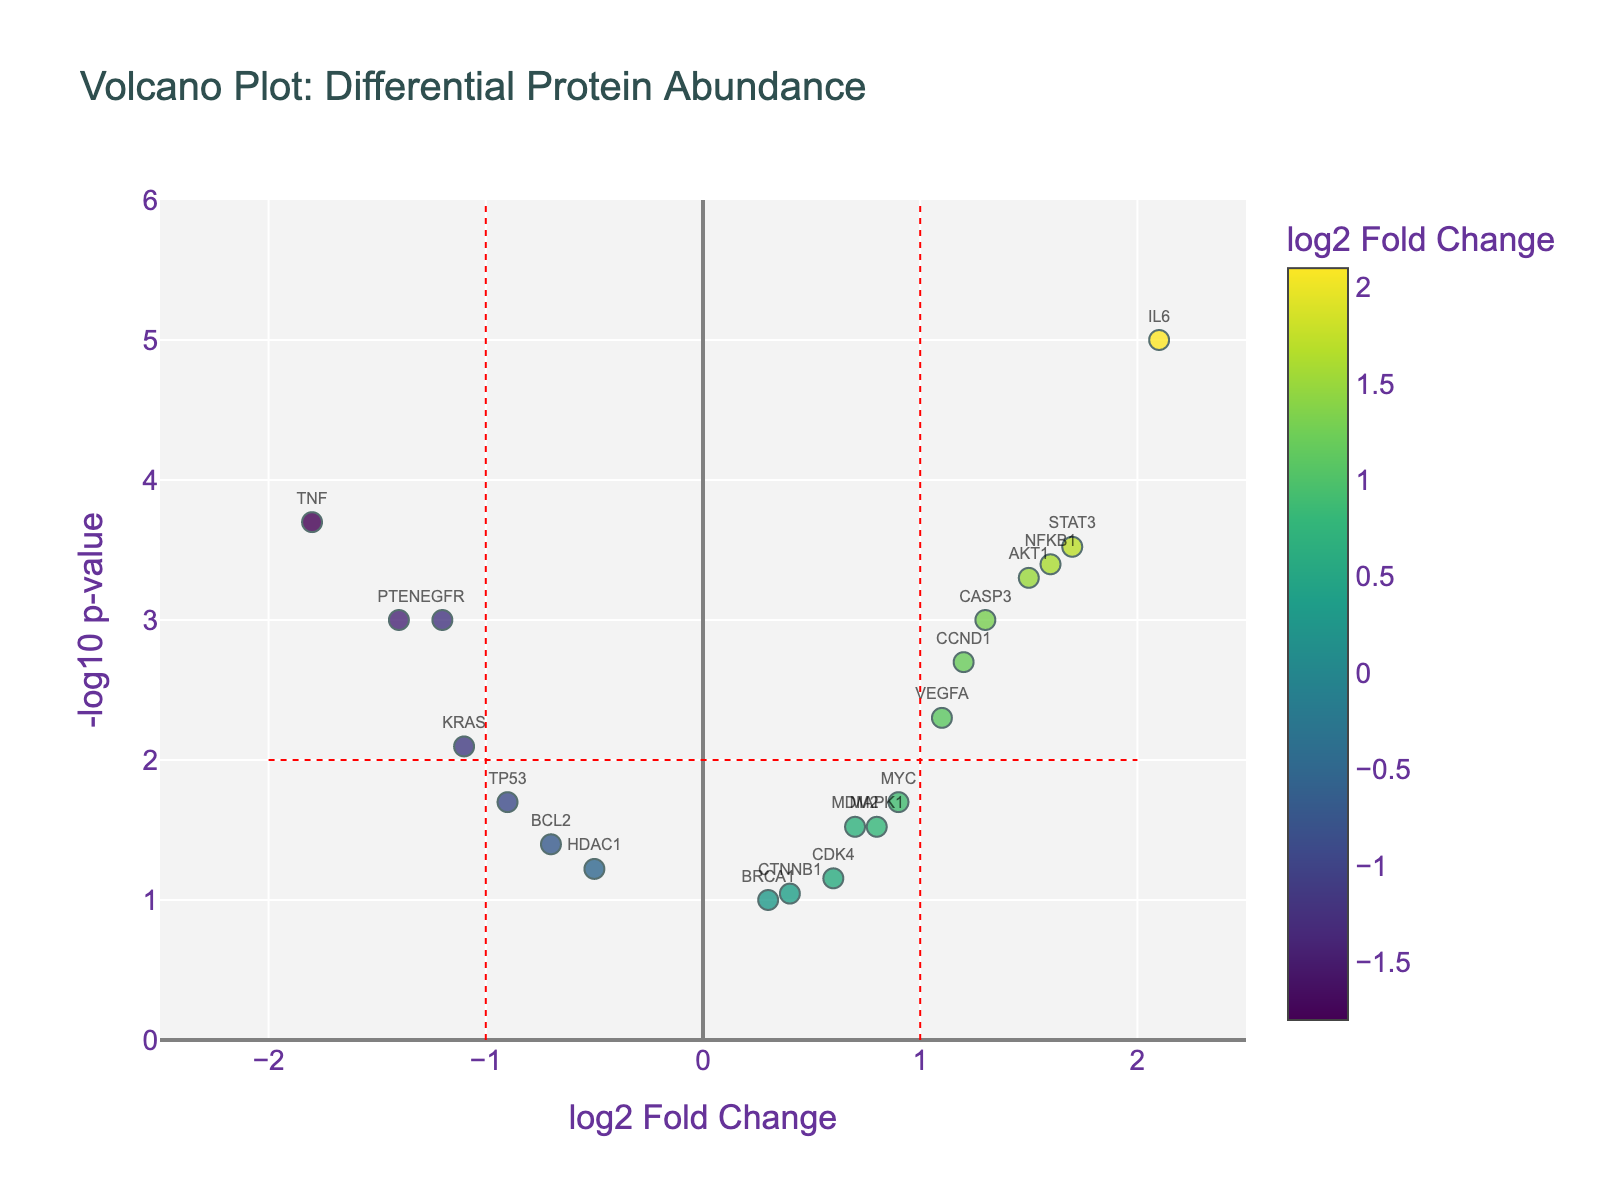Which protein shows the highest log2 fold change? By examining the x-axis (log2 Fold Change), we can see that IL6 has the highest value at 2.1, which is furthest to the right on the plot.
Answer: IL6 Which protein has the lowest p-value? By examining the y-axis (-log10 p-value), we find that IL6 has the highest -log10 p-value, indicating the lowest p-value of 0.00001.
Answer: IL6 Which proteins are significantly upregulated (log2 fold change > 1)? Proteins with log2 fold change > 1 are AKT1, STAT3, CCND1, VEGFA, and CASP3. These are visible on the right side of the vertical line at log2 fold change = 1.
Answer: AKT1, STAT3, CCND1, VEGFA, CASP3 How many proteins have a log2 fold change between -1 and 1? We count the data points between the vertical lines at -1 and 1 on the x-axis. These proteins are BRCA1, CDK4, CTNNB1, HDAC1, and MDM2.
Answer: 5 Which downregulated protein (negative log2 fold change) has the most significant p-value? Among the downregulated proteins, TNF has the highest -log10 p-value (value shown highest on the y-axis for downregulated proteins).
Answer: TNF Are there more significantly upregulated proteins or downregulated proteins (log2 fold change beyond ±1 and -log10 p-value > 2)? Counting proteins beyond the vertical lines at ±1 and above the horizontal line at -log10 p-value > 2, there are more upregulated proteins: 3 downregulated (TNF, EGFR, PTEN) and 5 upregulated (AKT1, IL6, STAT3, VEGFA, CCND1).
Answer: More upregulated What is the log2 fold change of TP53, and how does it compare to NFKB1? TP53 has a log2 fold change of -0.9, and NFKB1 has a log2 fold change of 1.6. NFKB1 is significantly higher than TP53.
Answer: NFKB1 > TP53 Count the number of proteins with insignificant regulation (p-value > 0.05). Counting proteins above -log10 p-value < 1.3, which corresponds to p-value > 0.05, only BRCA1 and CTNNB1 fall below this threshold.
Answer: 2 